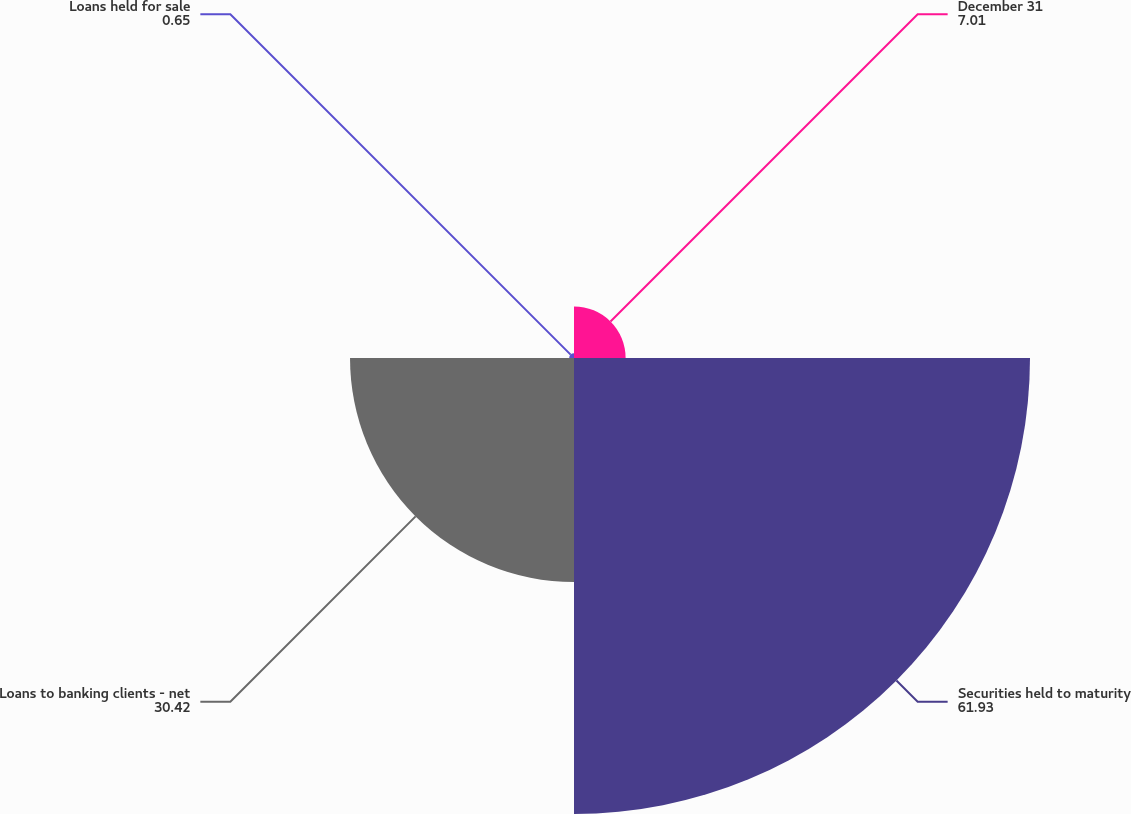Convert chart. <chart><loc_0><loc_0><loc_500><loc_500><pie_chart><fcel>December 31<fcel>Securities held to maturity<fcel>Loans to banking clients - net<fcel>Loans held for sale<nl><fcel>7.01%<fcel>61.93%<fcel>30.42%<fcel>0.65%<nl></chart> 